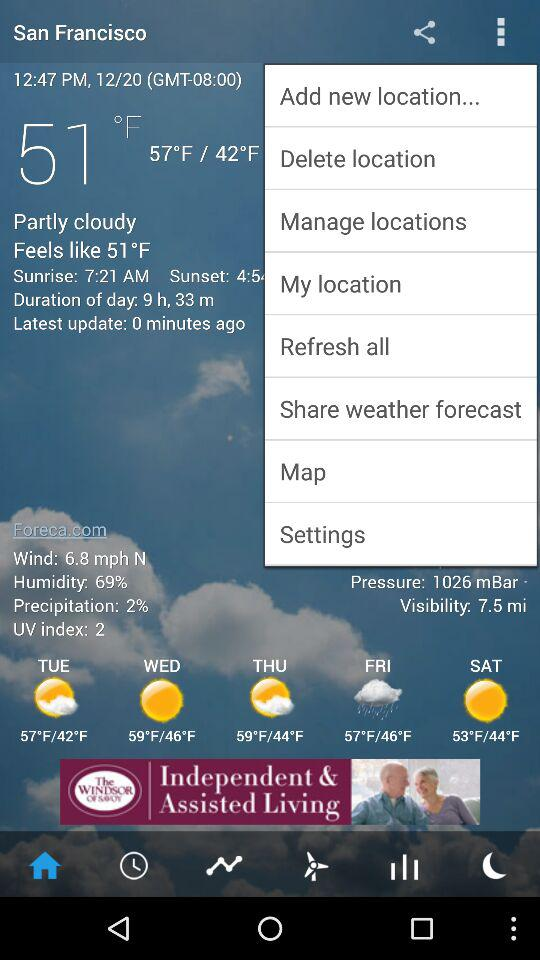What is the weather like on Tuesday? The weather is partly cloudy. 